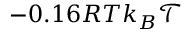<formula> <loc_0><loc_0><loc_500><loc_500>- 0 . 1 6 R T k _ { B } \mathcal { T }</formula> 